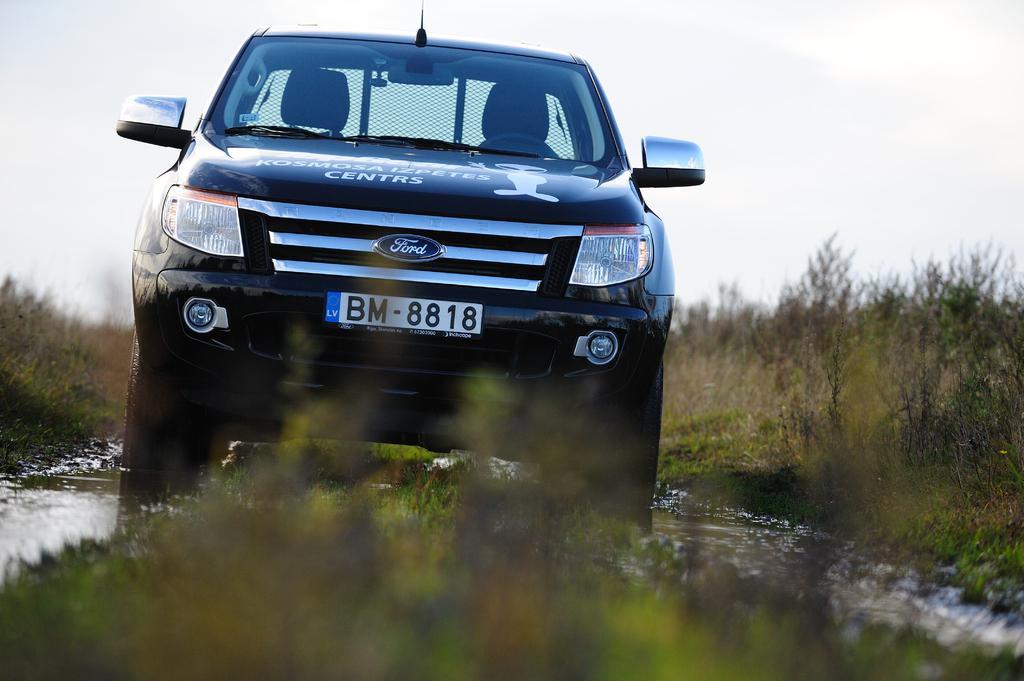Could you give a brief overview of what you see in this image? In this picture we can see a car on water, grass, trees and in the background we can see the sky. 